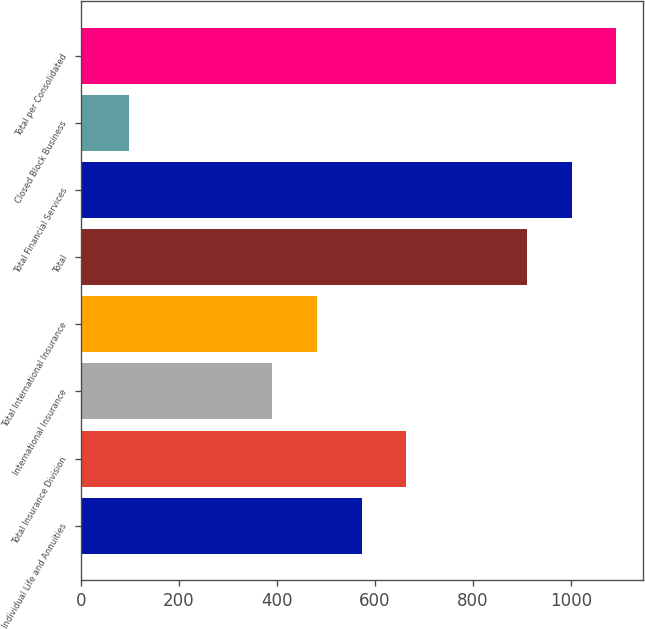<chart> <loc_0><loc_0><loc_500><loc_500><bar_chart><fcel>Individual Life and Annuities<fcel>Total Insurance Division<fcel>International Insurance<fcel>Total International Insurance<fcel>Total<fcel>Total Financial Services<fcel>Closed Block Business<fcel>Total per Consolidated<nl><fcel>572.8<fcel>664.2<fcel>390<fcel>481.4<fcel>910<fcel>1001.4<fcel>99<fcel>1092.8<nl></chart> 